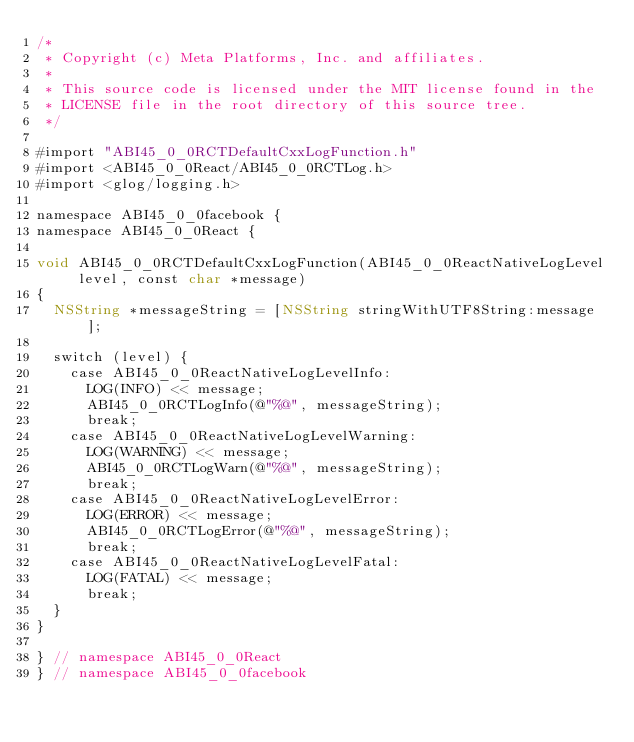<code> <loc_0><loc_0><loc_500><loc_500><_ObjectiveC_>/*
 * Copyright (c) Meta Platforms, Inc. and affiliates.
 *
 * This source code is licensed under the MIT license found in the
 * LICENSE file in the root directory of this source tree.
 */

#import "ABI45_0_0RCTDefaultCxxLogFunction.h"
#import <ABI45_0_0React/ABI45_0_0RCTLog.h>
#import <glog/logging.h>

namespace ABI45_0_0facebook {
namespace ABI45_0_0React {

void ABI45_0_0RCTDefaultCxxLogFunction(ABI45_0_0ReactNativeLogLevel level, const char *message)
{
  NSString *messageString = [NSString stringWithUTF8String:message];

  switch (level) {
    case ABI45_0_0ReactNativeLogLevelInfo:
      LOG(INFO) << message;
      ABI45_0_0RCTLogInfo(@"%@", messageString);
      break;
    case ABI45_0_0ReactNativeLogLevelWarning:
      LOG(WARNING) << message;
      ABI45_0_0RCTLogWarn(@"%@", messageString);
      break;
    case ABI45_0_0ReactNativeLogLevelError:
      LOG(ERROR) << message;
      ABI45_0_0RCTLogError(@"%@", messageString);
      break;
    case ABI45_0_0ReactNativeLogLevelFatal:
      LOG(FATAL) << message;
      break;
  }
}

} // namespace ABI45_0_0React
} // namespace ABI45_0_0facebook
</code> 